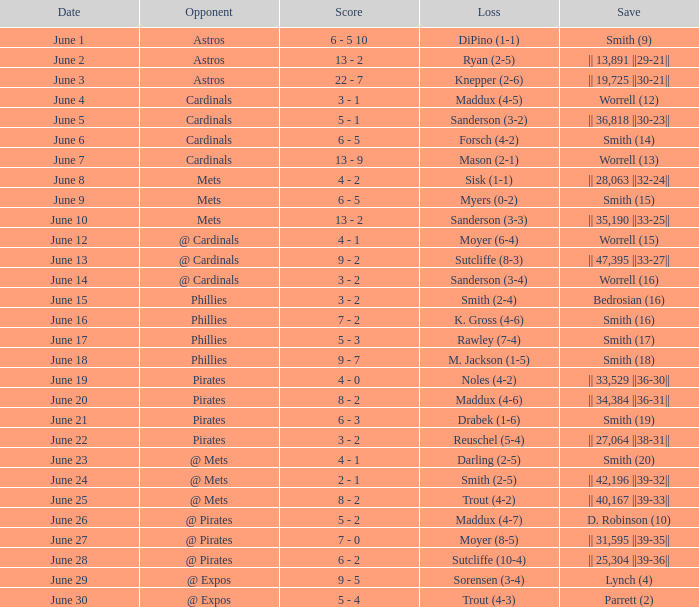The game that has a save of lynch (4) ended with what score? 9 - 5. 